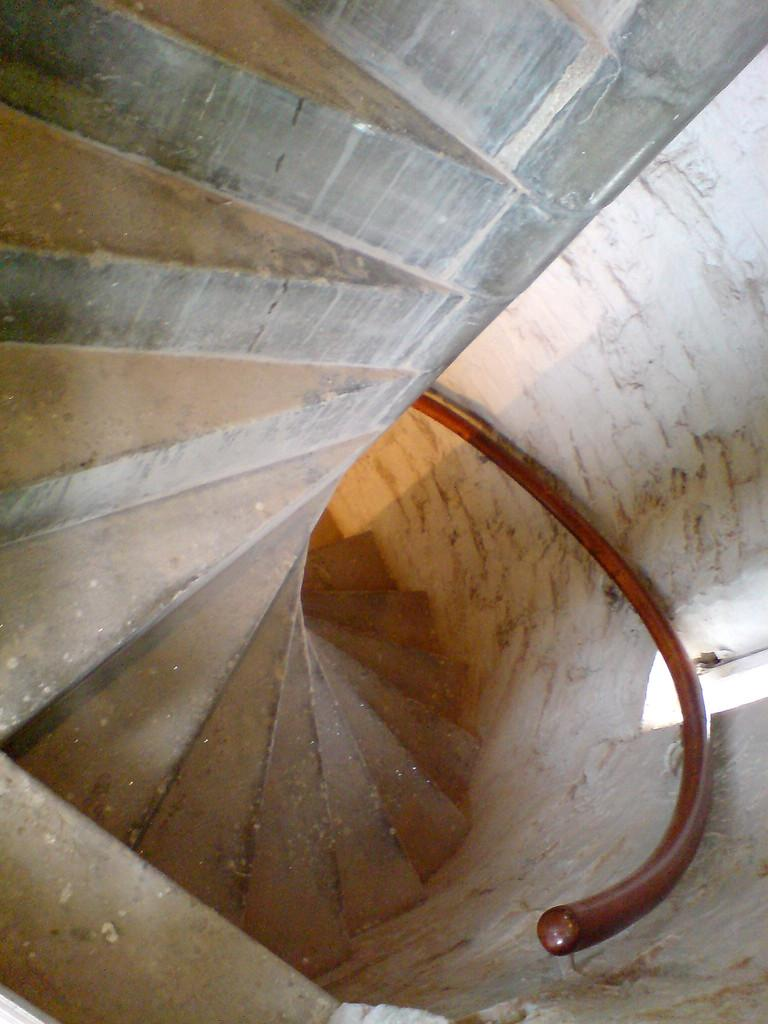What is the color of the wall in the image? The wall in the image is white. What architectural feature is present in the image? There are stairs in the image. Is there a baseball game happening on the stairs in the image? There is no indication of a baseball game or any sports activity in the image; it features a white color wall and stairs. Can you see a monkey climbing the wall in the image? There is no monkey present in the image; it only features a white color wall and stairs. 